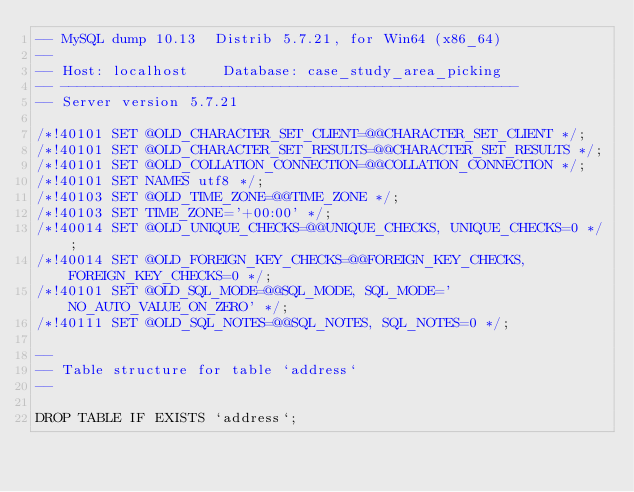<code> <loc_0><loc_0><loc_500><loc_500><_SQL_>-- MySQL dump 10.13  Distrib 5.7.21, for Win64 (x86_64)
--
-- Host: localhost    Database: case_study_area_picking
-- ------------------------------------------------------
-- Server version	5.7.21

/*!40101 SET @OLD_CHARACTER_SET_CLIENT=@@CHARACTER_SET_CLIENT */;
/*!40101 SET @OLD_CHARACTER_SET_RESULTS=@@CHARACTER_SET_RESULTS */;
/*!40101 SET @OLD_COLLATION_CONNECTION=@@COLLATION_CONNECTION */;
/*!40101 SET NAMES utf8 */;
/*!40103 SET @OLD_TIME_ZONE=@@TIME_ZONE */;
/*!40103 SET TIME_ZONE='+00:00' */;
/*!40014 SET @OLD_UNIQUE_CHECKS=@@UNIQUE_CHECKS, UNIQUE_CHECKS=0 */;
/*!40014 SET @OLD_FOREIGN_KEY_CHECKS=@@FOREIGN_KEY_CHECKS, FOREIGN_KEY_CHECKS=0 */;
/*!40101 SET @OLD_SQL_MODE=@@SQL_MODE, SQL_MODE='NO_AUTO_VALUE_ON_ZERO' */;
/*!40111 SET @OLD_SQL_NOTES=@@SQL_NOTES, SQL_NOTES=0 */;

--
-- Table structure for table `address`
--

DROP TABLE IF EXISTS `address`;</code> 